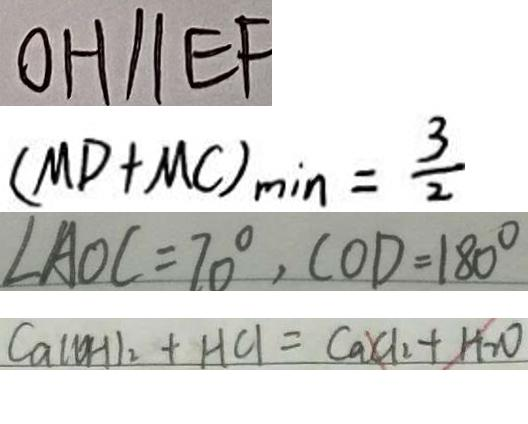Convert formula to latex. <formula><loc_0><loc_0><loc_500><loc_500>0 H / / E F 
 ( M D + M C ) _ { \min } = \frac { 3 } { 2 } 
 \angle A O C = 7 0 ^ { \circ } , C O D = 1 8 0 ^ { \circ } 
 C a ( O H ) _ { 2 } + H C l = C a C l _ { 2 } + H _ { 2 } O</formula> 